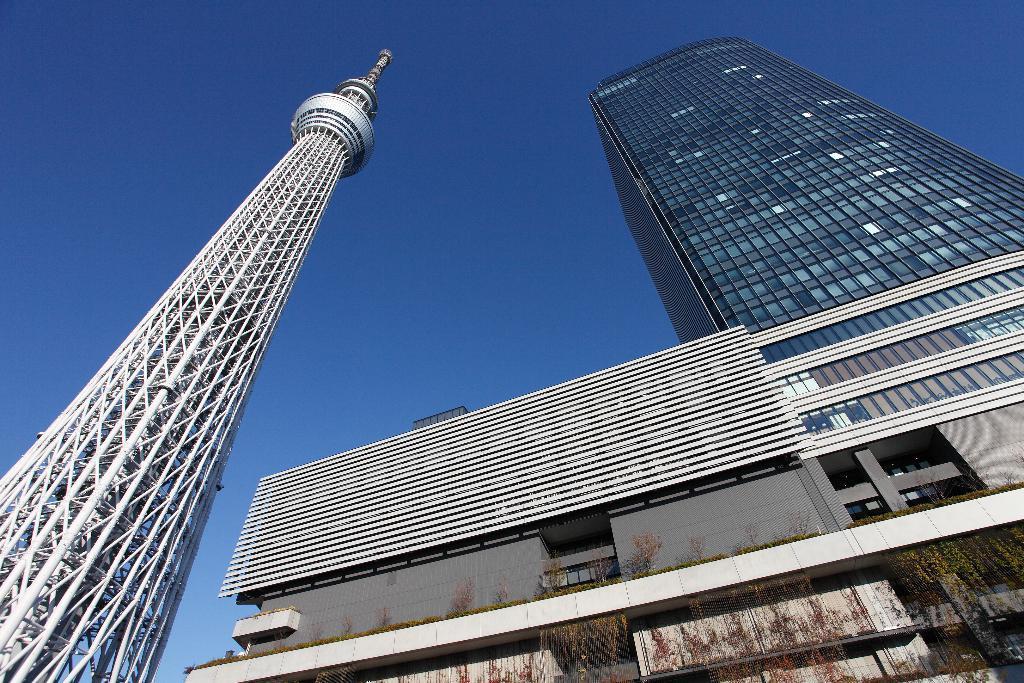Please provide a concise description of this image. In this image I see the buildings and I see a tower over here and I see the plants and in the background I see the blue sky. 